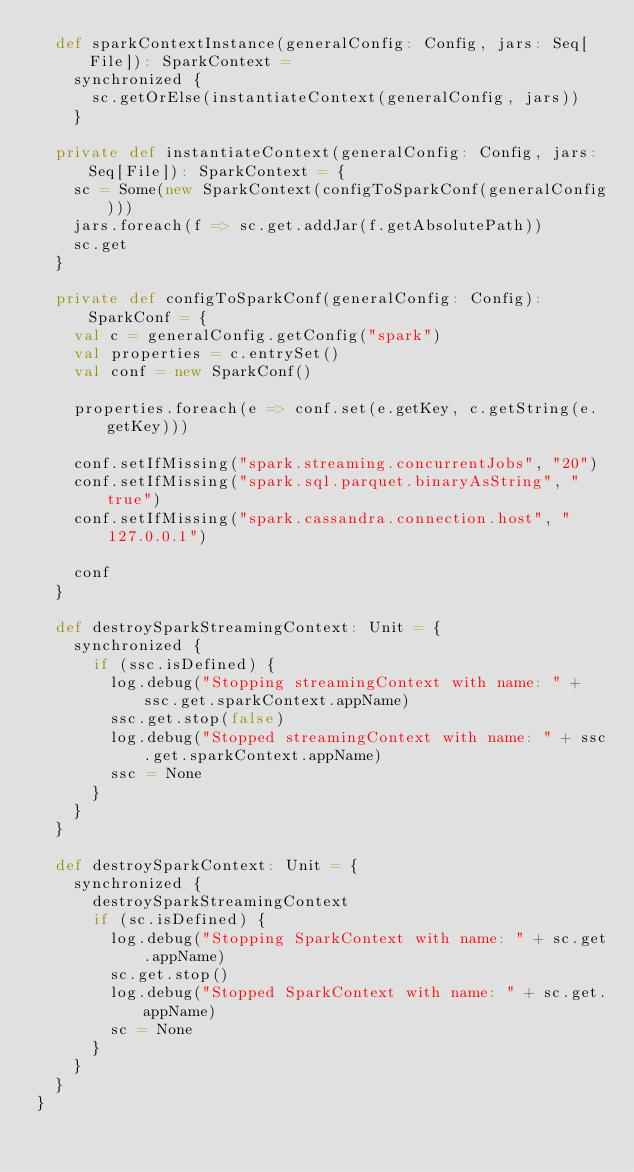<code> <loc_0><loc_0><loc_500><loc_500><_Scala_>  def sparkContextInstance(generalConfig: Config, jars: Seq[File]): SparkContext =
    synchronized {
      sc.getOrElse(instantiateContext(generalConfig, jars))
    }

  private def instantiateContext(generalConfig: Config, jars: Seq[File]): SparkContext = {
    sc = Some(new SparkContext(configToSparkConf(generalConfig)))
    jars.foreach(f => sc.get.addJar(f.getAbsolutePath))
    sc.get
  }

  private def configToSparkConf(generalConfig: Config): SparkConf = {
    val c = generalConfig.getConfig("spark")
    val properties = c.entrySet()
    val conf = new SparkConf()

    properties.foreach(e => conf.set(e.getKey, c.getString(e.getKey)))

    conf.setIfMissing("spark.streaming.concurrentJobs", "20")
    conf.setIfMissing("spark.sql.parquet.binaryAsString", "true")
    conf.setIfMissing("spark.cassandra.connection.host", "127.0.0.1")

    conf
  }

  def destroySparkStreamingContext: Unit = {
    synchronized {
      if (ssc.isDefined) {
        log.debug("Stopping streamingContext with name: " + ssc.get.sparkContext.appName)
        ssc.get.stop(false)
        log.debug("Stopped streamingContext with name: " + ssc.get.sparkContext.appName)
        ssc = None
      }
    }
  }

  def destroySparkContext: Unit = {
    synchronized {
      destroySparkStreamingContext
      if (sc.isDefined) {
        log.debug("Stopping SparkContext with name: " + sc.get.appName)
        sc.get.stop()
        log.debug("Stopped SparkContext with name: " + sc.get.appName)
        sc = None
      }
    }
  }
}
</code> 